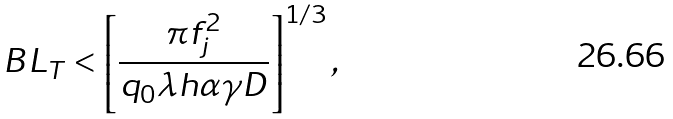Convert formula to latex. <formula><loc_0><loc_0><loc_500><loc_500>B L _ { T } < \left [ \frac { \pi f _ { j } ^ { 2 } } { q _ { 0 } \lambda h \alpha \gamma D } \right ] ^ { 1 / 3 } ,</formula> 